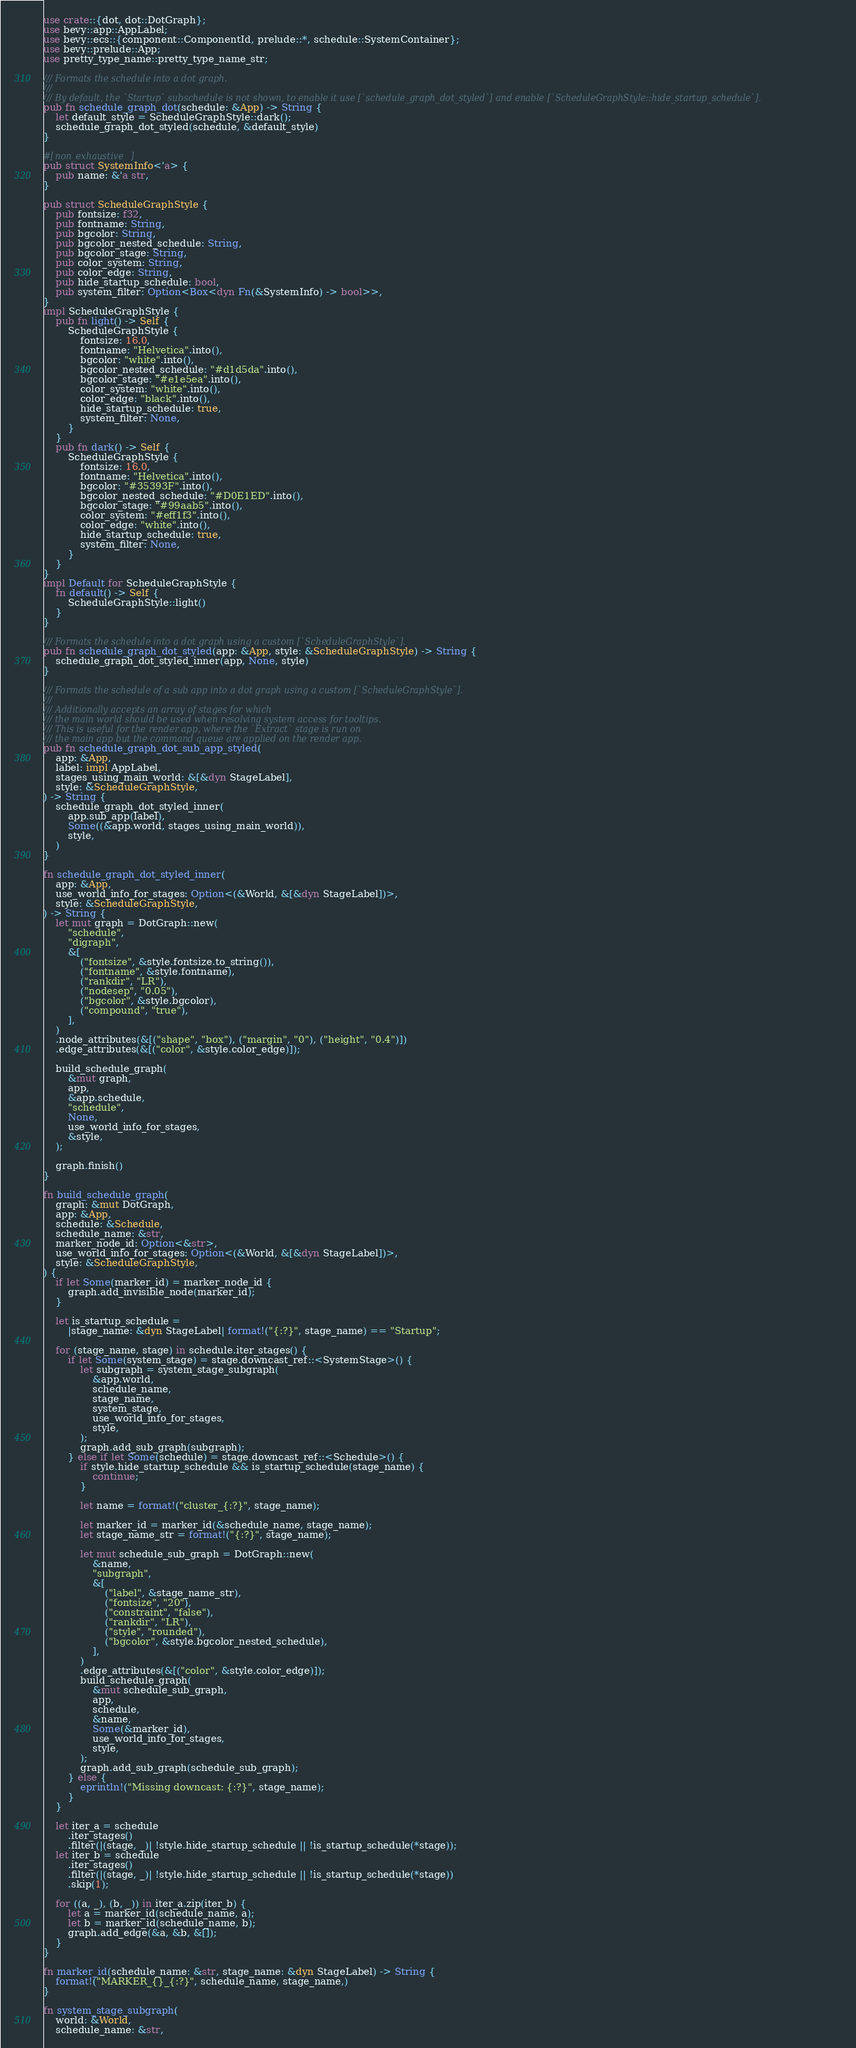Convert code to text. <code><loc_0><loc_0><loc_500><loc_500><_Rust_>use crate::{dot, dot::DotGraph};
use bevy::app::AppLabel;
use bevy::ecs::{component::ComponentId, prelude::*, schedule::SystemContainer};
use bevy::prelude::App;
use pretty_type_name::pretty_type_name_str;

/// Formats the schedule into a dot graph.
///
/// By default, the `Startup` subschedule is not shown, to enable it use [`schedule_graph_dot_styled`] and enable [`ScheduleGraphStyle::hide_startup_schedule`].
pub fn schedule_graph_dot(schedule: &App) -> String {
    let default_style = ScheduleGraphStyle::dark();
    schedule_graph_dot_styled(schedule, &default_style)
}

#[non_exhaustive]
pub struct SystemInfo<'a> {
    pub name: &'a str,
}

pub struct ScheduleGraphStyle {
    pub fontsize: f32,
    pub fontname: String,
    pub bgcolor: String,
    pub bgcolor_nested_schedule: String,
    pub bgcolor_stage: String,
    pub color_system: String,
    pub color_edge: String,
    pub hide_startup_schedule: bool,
    pub system_filter: Option<Box<dyn Fn(&SystemInfo) -> bool>>,
}
impl ScheduleGraphStyle {
    pub fn light() -> Self {
        ScheduleGraphStyle {
            fontsize: 16.0,
            fontname: "Helvetica".into(),
            bgcolor: "white".into(),
            bgcolor_nested_schedule: "#d1d5da".into(),
            bgcolor_stage: "#e1e5ea".into(),
            color_system: "white".into(),
            color_edge: "black".into(),
            hide_startup_schedule: true,
            system_filter: None,
        }
    }
    pub fn dark() -> Self {
        ScheduleGraphStyle {
            fontsize: 16.0,
            fontname: "Helvetica".into(),
            bgcolor: "#35393F".into(),
            bgcolor_nested_schedule: "#D0E1ED".into(),
            bgcolor_stage: "#99aab5".into(),
            color_system: "#eff1f3".into(),
            color_edge: "white".into(),
            hide_startup_schedule: true,
            system_filter: None,
        }
    }
}
impl Default for ScheduleGraphStyle {
    fn default() -> Self {
        ScheduleGraphStyle::light()
    }
}

/// Formats the schedule into a dot graph using a custom [`ScheduleGraphStyle`].
pub fn schedule_graph_dot_styled(app: &App, style: &ScheduleGraphStyle) -> String {
    schedule_graph_dot_styled_inner(app, None, style)
}

/// Formats the schedule of a sub app into a dot graph using a custom [`ScheduleGraphStyle`].
///
/// Additionally accepts an array of stages for which
/// the main world should be used when resolving system access for tooltips.
/// This is useful for the render app, where the `Extract` stage is run on
/// the main app but the command queue are applied on the render app.
pub fn schedule_graph_dot_sub_app_styled(
    app: &App,
    label: impl AppLabel,
    stages_using_main_world: &[&dyn StageLabel],
    style: &ScheduleGraphStyle,
) -> String {
    schedule_graph_dot_styled_inner(
        app.sub_app(label),
        Some((&app.world, stages_using_main_world)),
        style,
    )
}

fn schedule_graph_dot_styled_inner(
    app: &App,
    use_world_info_for_stages: Option<(&World, &[&dyn StageLabel])>,
    style: &ScheduleGraphStyle,
) -> String {
    let mut graph = DotGraph::new(
        "schedule",
        "digraph",
        &[
            ("fontsize", &style.fontsize.to_string()),
            ("fontname", &style.fontname),
            ("rankdir", "LR"),
            ("nodesep", "0.05"),
            ("bgcolor", &style.bgcolor),
            ("compound", "true"),
        ],
    )
    .node_attributes(&[("shape", "box"), ("margin", "0"), ("height", "0.4")])
    .edge_attributes(&[("color", &style.color_edge)]);

    build_schedule_graph(
        &mut graph,
        app,
        &app.schedule,
        "schedule",
        None,
        use_world_info_for_stages,
        &style,
    );

    graph.finish()
}

fn build_schedule_graph(
    graph: &mut DotGraph,
    app: &App,
    schedule: &Schedule,
    schedule_name: &str,
    marker_node_id: Option<&str>,
    use_world_info_for_stages: Option<(&World, &[&dyn StageLabel])>,
    style: &ScheduleGraphStyle,
) {
    if let Some(marker_id) = marker_node_id {
        graph.add_invisible_node(marker_id);
    }

    let is_startup_schedule =
        |stage_name: &dyn StageLabel| format!("{:?}", stage_name) == "Startup";

    for (stage_name, stage) in schedule.iter_stages() {
        if let Some(system_stage) = stage.downcast_ref::<SystemStage>() {
            let subgraph = system_stage_subgraph(
                &app.world,
                schedule_name,
                stage_name,
                system_stage,
                use_world_info_for_stages,
                style,
            );
            graph.add_sub_graph(subgraph);
        } else if let Some(schedule) = stage.downcast_ref::<Schedule>() {
            if style.hide_startup_schedule && is_startup_schedule(stage_name) {
                continue;
            }

            let name = format!("cluster_{:?}", stage_name);

            let marker_id = marker_id(&schedule_name, stage_name);
            let stage_name_str = format!("{:?}", stage_name);

            let mut schedule_sub_graph = DotGraph::new(
                &name,
                "subgraph",
                &[
                    ("label", &stage_name_str),
                    ("fontsize", "20"),
                    ("constraint", "false"),
                    ("rankdir", "LR"),
                    ("style", "rounded"),
                    ("bgcolor", &style.bgcolor_nested_schedule),
                ],
            )
            .edge_attributes(&[("color", &style.color_edge)]);
            build_schedule_graph(
                &mut schedule_sub_graph,
                app,
                schedule,
                &name,
                Some(&marker_id),
                use_world_info_for_stages,
                style,
            );
            graph.add_sub_graph(schedule_sub_graph);
        } else {
            eprintln!("Missing downcast: {:?}", stage_name);
        }
    }

    let iter_a = schedule
        .iter_stages()
        .filter(|(stage, _)| !style.hide_startup_schedule || !is_startup_schedule(*stage));
    let iter_b = schedule
        .iter_stages()
        .filter(|(stage, _)| !style.hide_startup_schedule || !is_startup_schedule(*stage))
        .skip(1);

    for ((a, _), (b, _)) in iter_a.zip(iter_b) {
        let a = marker_id(schedule_name, a);
        let b = marker_id(schedule_name, b);
        graph.add_edge(&a, &b, &[]);
    }
}

fn marker_id(schedule_name: &str, stage_name: &dyn StageLabel) -> String {
    format!("MARKER_{}_{:?}", schedule_name, stage_name,)
}

fn system_stage_subgraph(
    world: &World,
    schedule_name: &str,</code> 